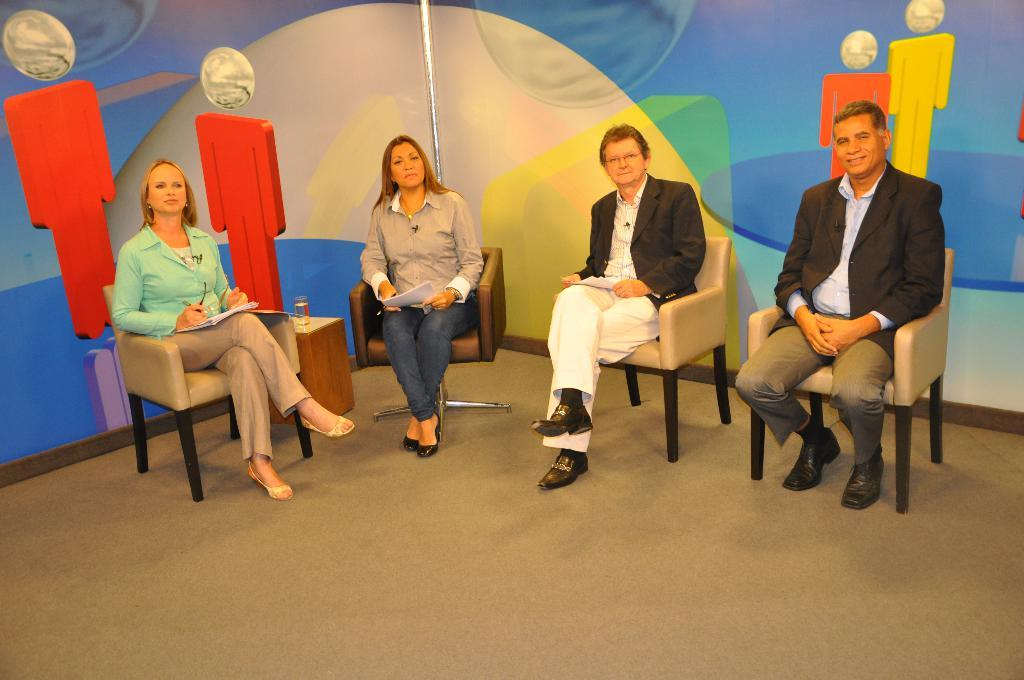What are the people in the image doing? The people in the image are sitting on chairs. What else can be seen in the image besides the people? There is a banner visible in the image. Where is the key to the can located in the image? There is no key or can present in the image. 